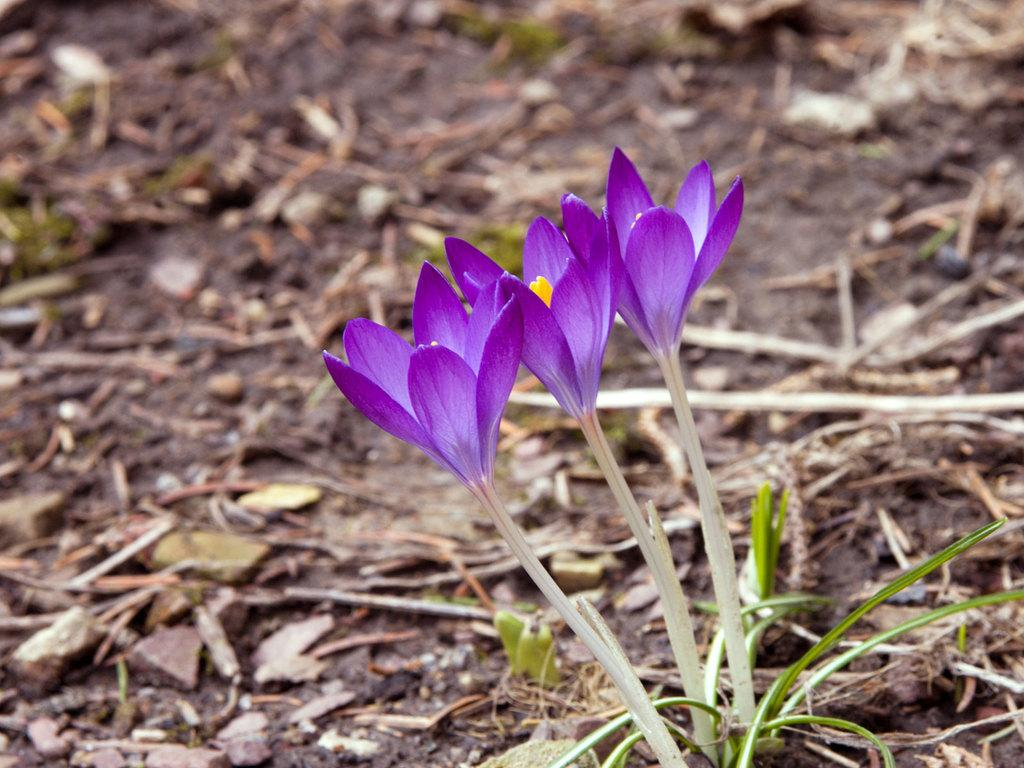What type of plants can be seen in the image? There are flowers in the image. What colors are the flowers? The flowers are purple and yellow in color. What type of vegetation is visible in the image besides the flowers? There is grass visible in the image. How would you describe the background of the image? The background is blurred. What type of knife is being used to cut the flowers in the image? There is no knife present in the image, and the flowers are not being cut. 